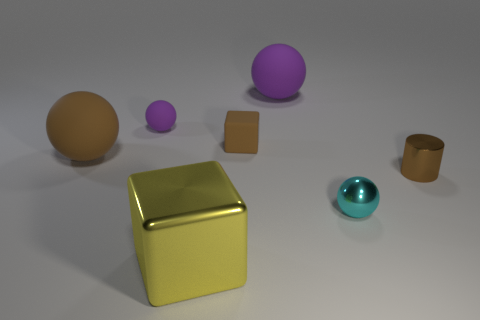Is there anything else that has the same shape as the small brown shiny thing?
Offer a very short reply. No. The purple sphere on the left side of the matte sphere behind the tiny ball that is on the left side of the tiny cyan metal ball is made of what material?
Make the answer very short. Rubber. Are there any cyan balls of the same size as the brown block?
Give a very brief answer. Yes. The big matte sphere that is in front of the purple sphere that is left of the large block is what color?
Make the answer very short. Brown. What number of big brown matte cylinders are there?
Offer a very short reply. 0. Do the shiny cylinder and the matte cube have the same color?
Provide a succinct answer. Yes. Is the number of small purple matte things that are right of the brown rubber cube less than the number of brown rubber things that are in front of the big brown sphere?
Ensure brevity in your answer.  No. What color is the tiny shiny cylinder?
Your answer should be compact. Brown. How many metal cubes are the same color as the metallic ball?
Make the answer very short. 0. Are there any balls in front of the large purple ball?
Offer a very short reply. Yes. 